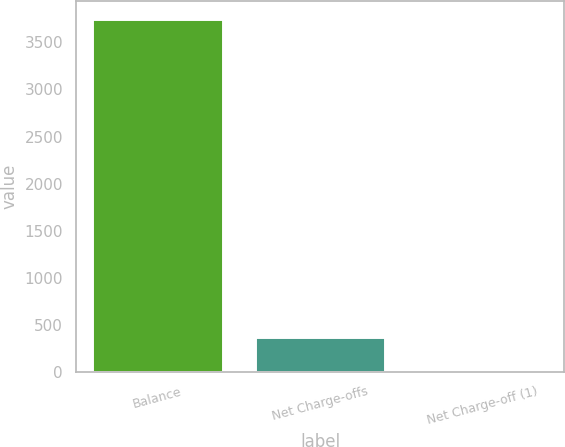Convert chart. <chart><loc_0><loc_0><loc_500><loc_500><bar_chart><fcel>Balance<fcel>Net Charge-offs<fcel>Net Charge-off (1)<nl><fcel>3752<fcel>375.89<fcel>0.77<nl></chart> 